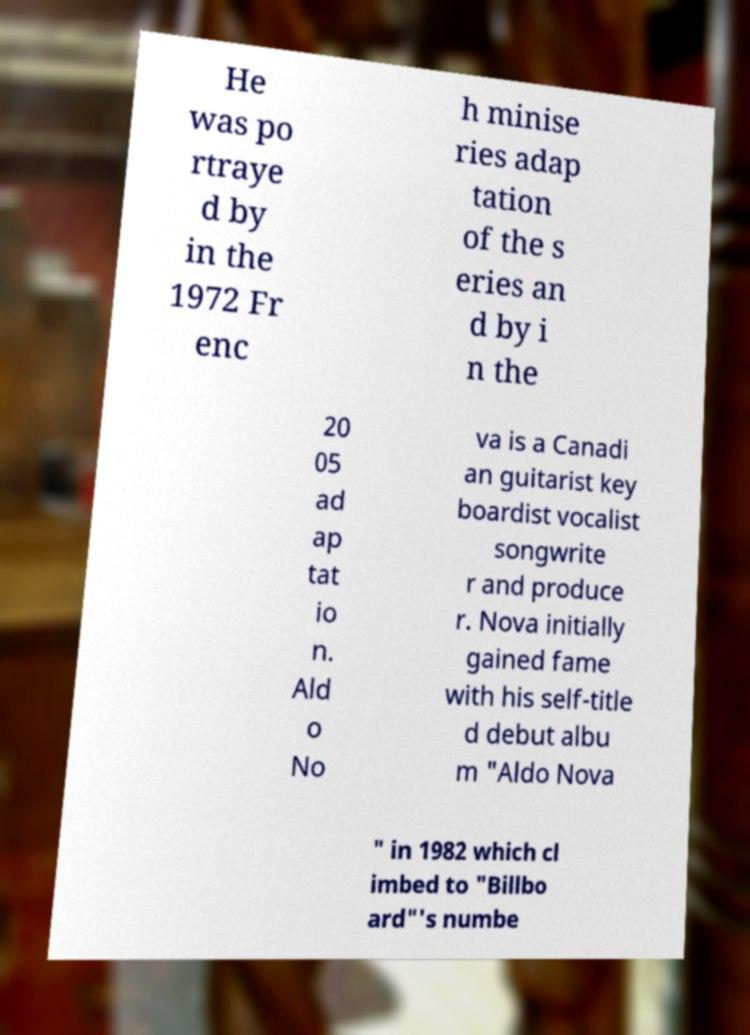Could you assist in decoding the text presented in this image and type it out clearly? He was po rtraye d by in the 1972 Fr enc h minise ries adap tation of the s eries an d by i n the 20 05 ad ap tat io n. Ald o No va is a Canadi an guitarist key boardist vocalist songwrite r and produce r. Nova initially gained fame with his self-title d debut albu m "Aldo Nova " in 1982 which cl imbed to "Billbo ard"'s numbe 